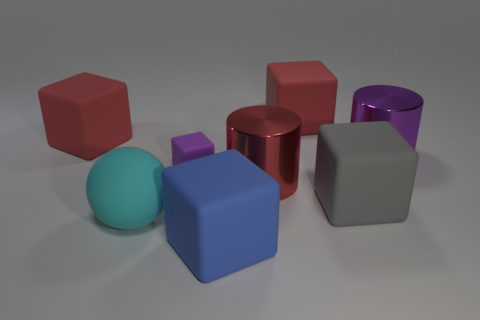What shape is the blue rubber thing that is the same size as the ball?
Your answer should be compact. Cube. Is there another large rubber object that has the same shape as the big blue rubber thing?
Provide a succinct answer. Yes. Does the large red block to the right of the large red shiny object have the same material as the cylinder to the right of the big gray matte object?
Your response must be concise. No. There is a big shiny thing that is the same color as the tiny rubber thing; what shape is it?
Provide a short and direct response. Cylinder. Does the purple object that is to the left of the large purple object have the same shape as the red matte object that is on the right side of the large blue matte block?
Provide a short and direct response. Yes. The large shiny cylinder that is in front of the purple metal cylinder is what color?
Give a very brief answer. Red. Is the number of big red rubber cubes right of the big red cylinder less than the number of matte cubes on the right side of the large blue thing?
Your answer should be compact. Yes. Is the material of the large gray object the same as the big red cylinder?
Keep it short and to the point. No. There is a purple thing that is left of the metal object that is behind the tiny rubber thing; how big is it?
Your response must be concise. Small. The big matte thing that is right of the big thing that is behind the cube that is on the left side of the sphere is what color?
Offer a terse response. Gray. 